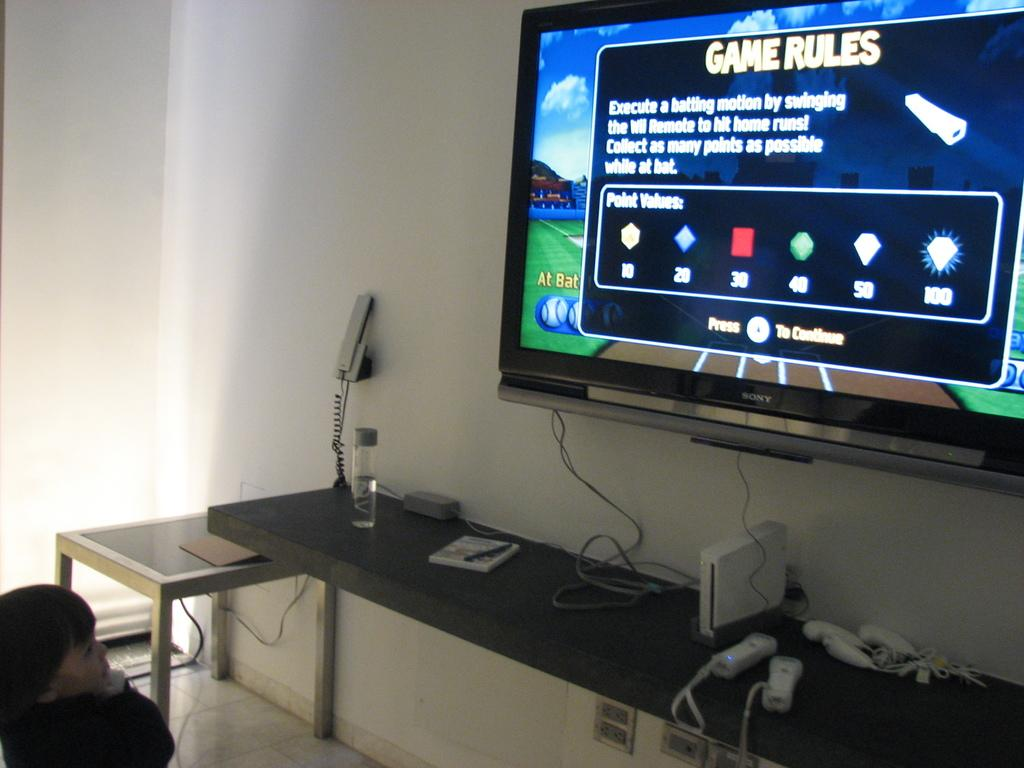What electronic device is mounted on the wall in the image? There is a television on the wall in the image. What other electronic device is mounted on the wall? There is a telephone on the wall in the image. Where is the kid located in the image? The kid is on the left side of the image. What can be seen behind the electronic devices on the wall? The wall is visible in the image. Can you describe the beggar sitting next to the television in the image? There is no beggar present in the image; only the television, telephone, and kid are visible. 